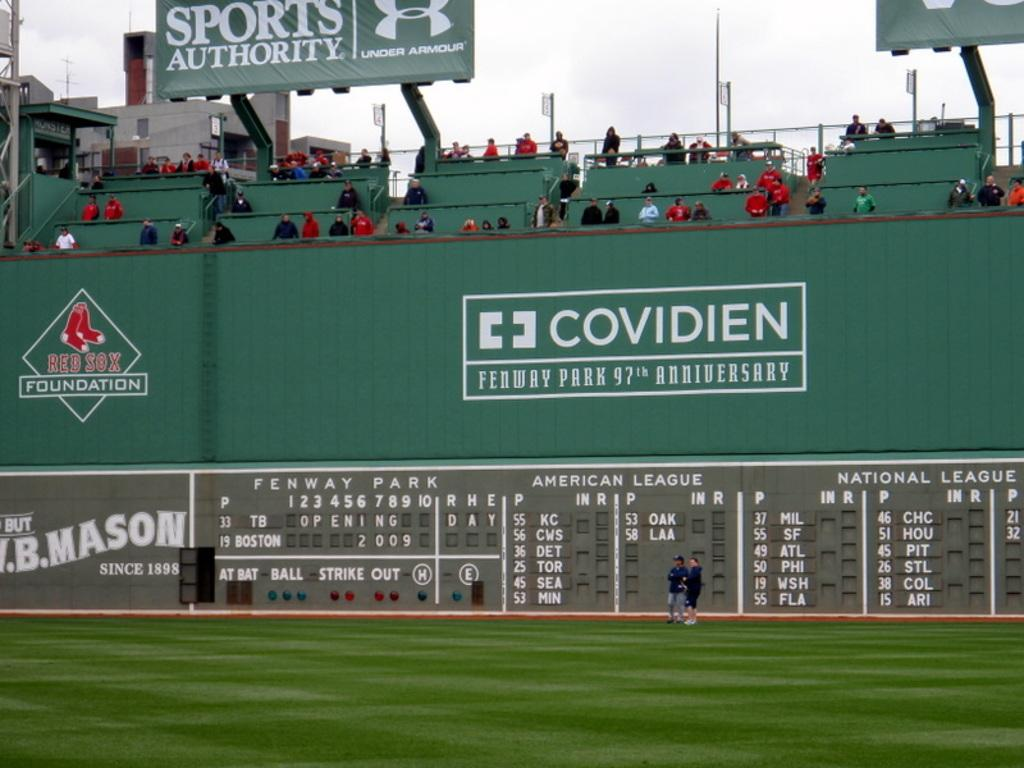<image>
Write a terse but informative summary of the picture. the big green monster at fenway ball park 